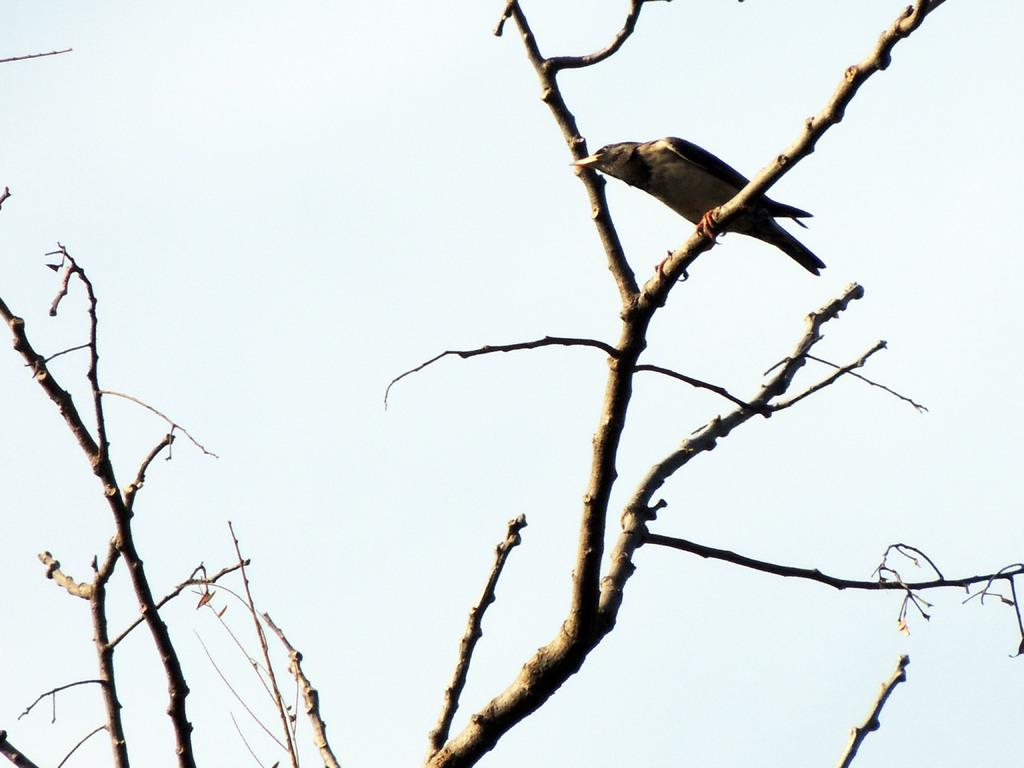What type of natural objects can be seen in the image? There are dried branches in the image. Is there any wildlife present in the image? Yes, a bird is on one of the branches. What can be seen in the background of the image? The sky is visible in the background of the image. What type of net is being used to catch the bird in the image? There is no net present in the image; the bird is simply perched on a branch. 